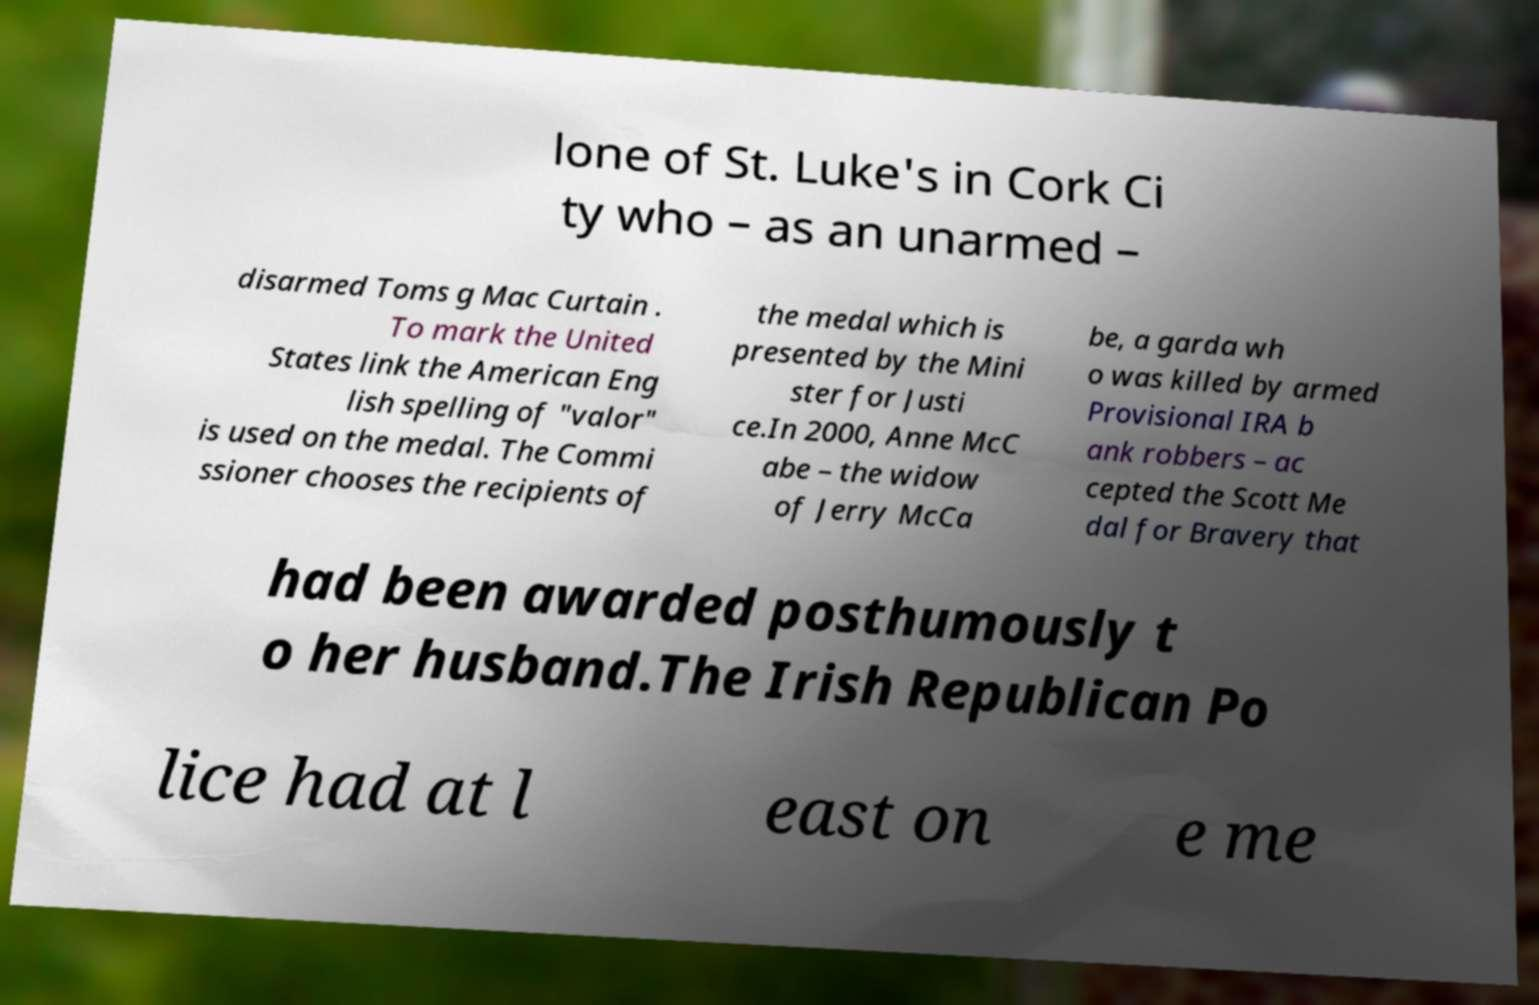Please read and relay the text visible in this image. What does it say? lone of St. Luke's in Cork Ci ty who – as an unarmed – disarmed Toms g Mac Curtain . To mark the United States link the American Eng lish spelling of "valor" is used on the medal. The Commi ssioner chooses the recipients of the medal which is presented by the Mini ster for Justi ce.In 2000, Anne McC abe – the widow of Jerry McCa be, a garda wh o was killed by armed Provisional IRA b ank robbers – ac cepted the Scott Me dal for Bravery that had been awarded posthumously t o her husband.The Irish Republican Po lice had at l east on e me 